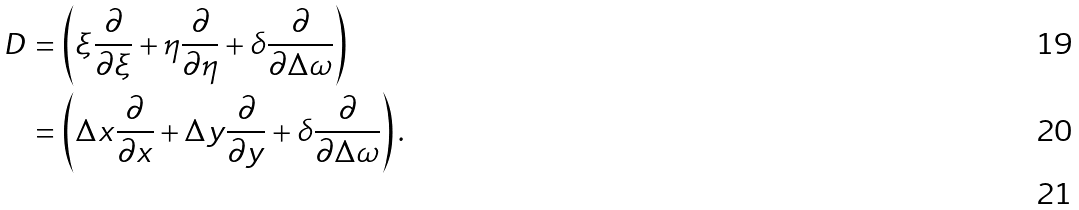Convert formula to latex. <formula><loc_0><loc_0><loc_500><loc_500>\ D & = \left ( \xi \frac { \partial } { \partial \xi } + \eta \frac { \partial } { \partial \eta } + \delta \frac { \partial } { \partial \Delta \omega } \right ) \\ & = \left ( \Delta x \frac { \partial } { \partial x } + \Delta y \frac { \partial } { \partial y } + \delta \frac { \partial } { \partial \Delta \omega } \right ) . \\</formula> 